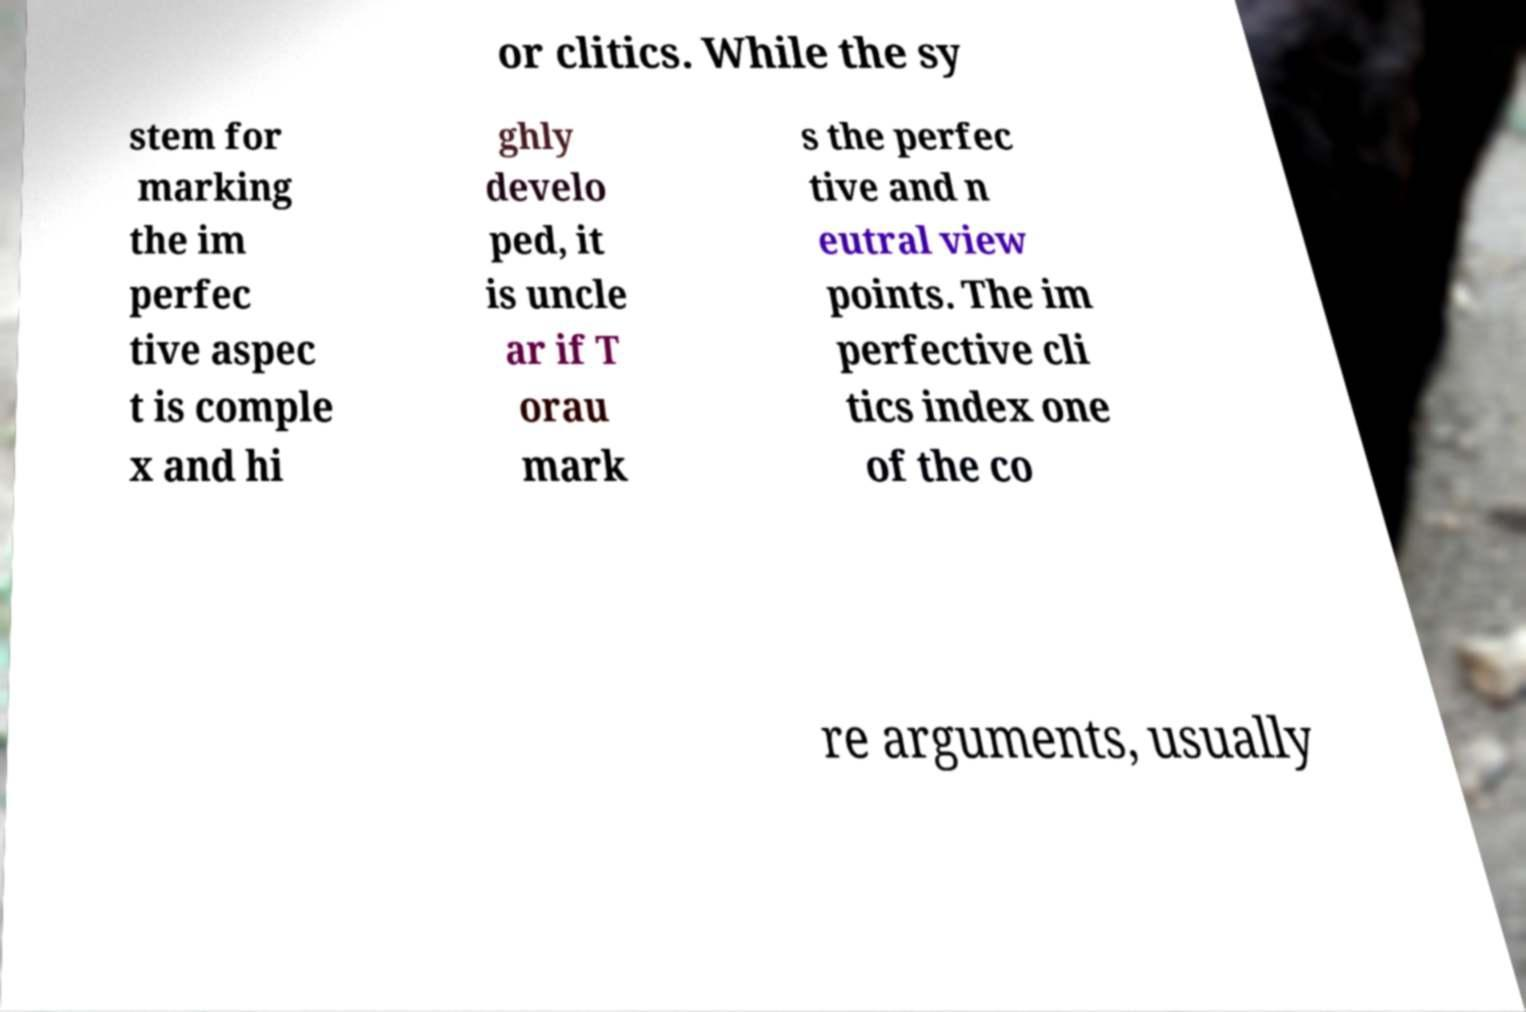For documentation purposes, I need the text within this image transcribed. Could you provide that? or clitics. While the sy stem for marking the im perfec tive aspec t is comple x and hi ghly develo ped, it is uncle ar if T orau mark s the perfec tive and n eutral view points. The im perfective cli tics index one of the co re arguments, usually 